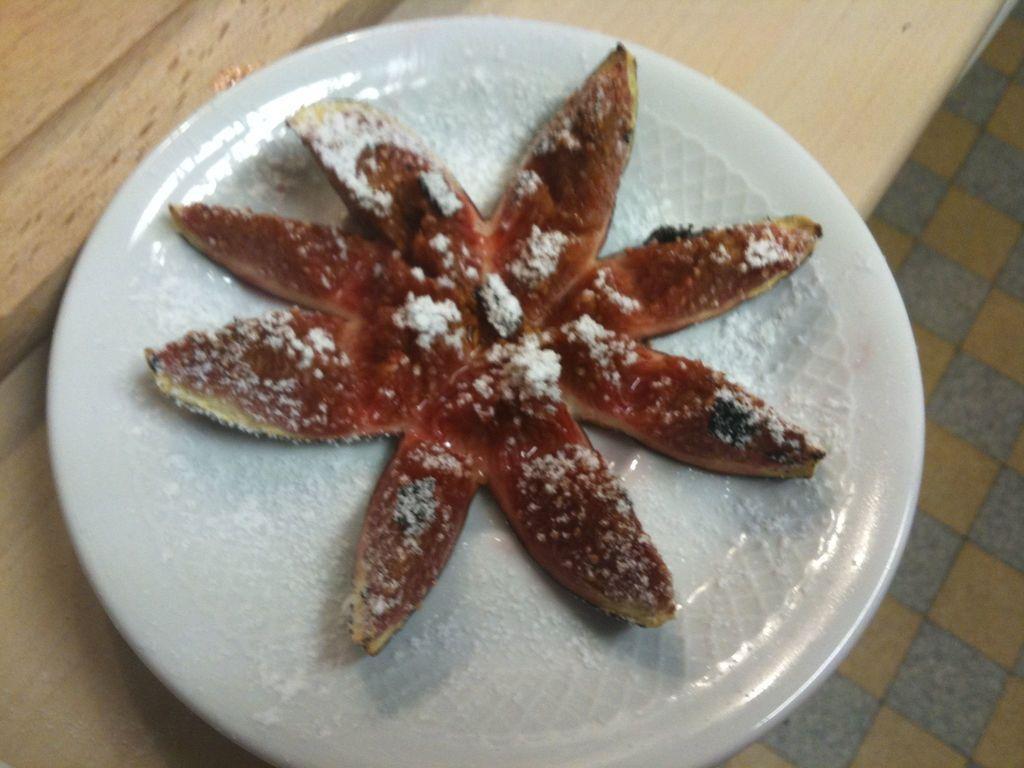Please provide a concise description of this image. In this image I can see the plate with food. The plate is in white color and the food is in red color. The plate is on the table. To the side I can see the floor. 